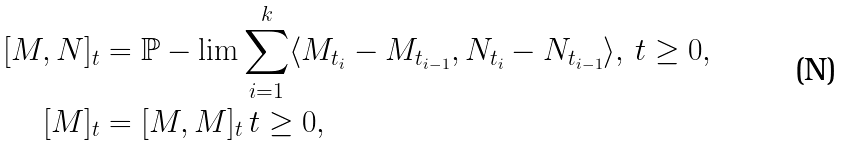Convert formula to latex. <formula><loc_0><loc_0><loc_500><loc_500>[ M , N ] _ { t } & = \mathbb { P } - \lim \sum _ { i = 1 } ^ { k } \langle M _ { t _ { i } } - M _ { t _ { i - 1 } } , N _ { t _ { i } } - N _ { t _ { i - 1 } } \rangle , \, t \geq 0 , \\ [ M ] _ { t } & = [ M , M ] _ { t } \, t \geq 0 ,</formula> 